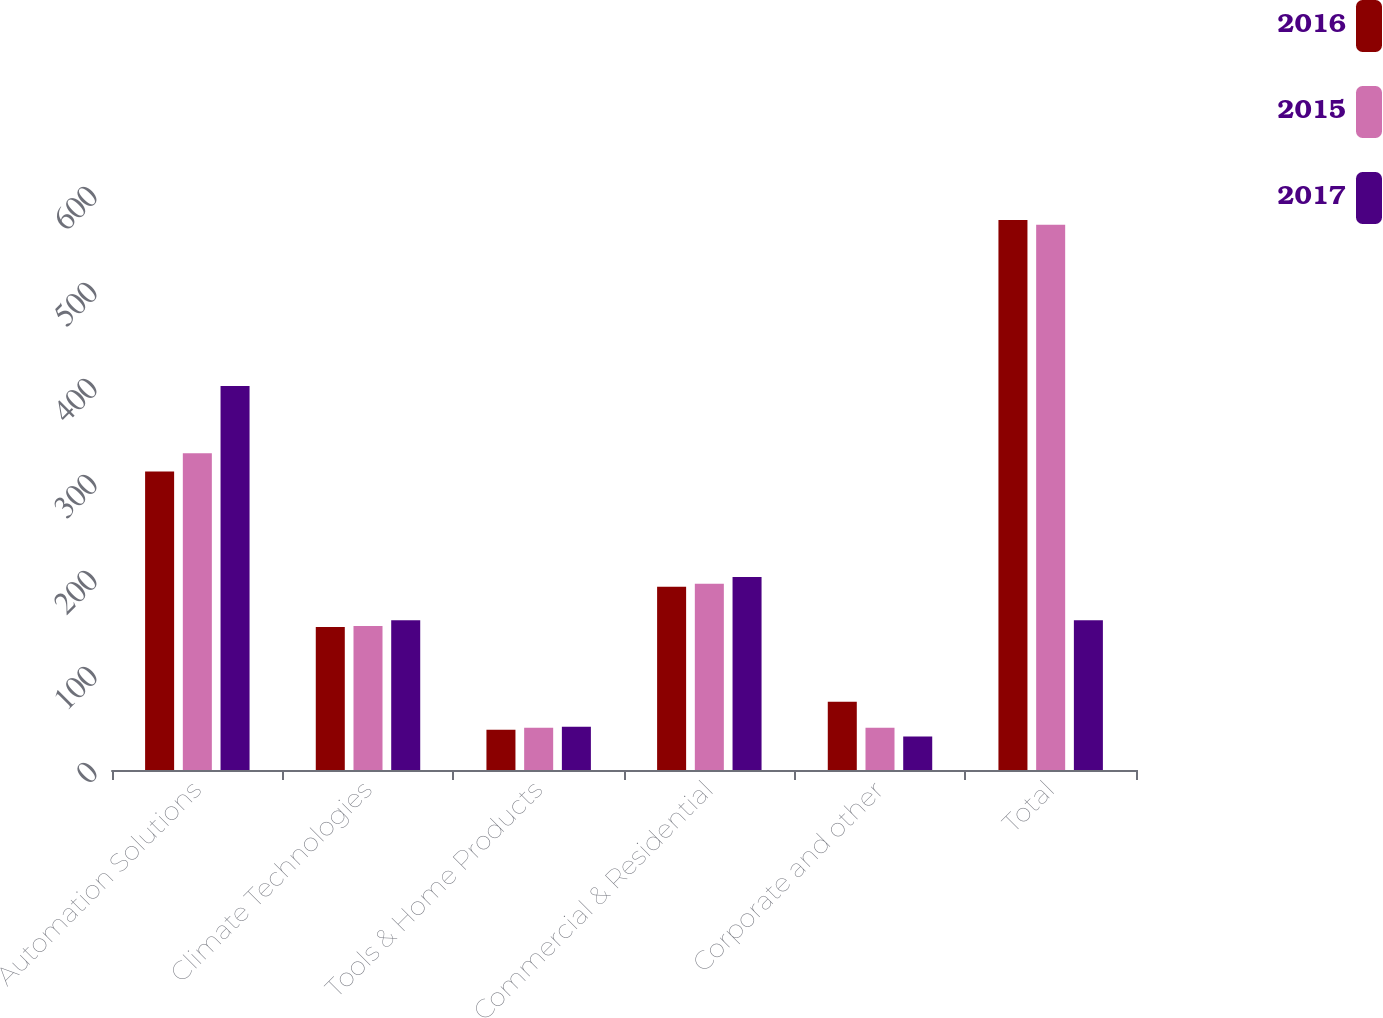Convert chart. <chart><loc_0><loc_0><loc_500><loc_500><stacked_bar_chart><ecel><fcel>Automation Solutions<fcel>Climate Technologies<fcel>Tools & Home Products<fcel>Commercial & Residential<fcel>Corporate and other<fcel>Total<nl><fcel>2016<fcel>311<fcel>149<fcel>42<fcel>191<fcel>71<fcel>573<nl><fcel>2015<fcel>330<fcel>150<fcel>44<fcel>194<fcel>44<fcel>568<nl><fcel>2017<fcel>400<fcel>156<fcel>45<fcel>201<fcel>35<fcel>156<nl></chart> 